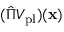Convert formula to latex. <formula><loc_0><loc_0><loc_500><loc_500>( \hat { \Pi } V _ { p l } ) ( x )</formula> 